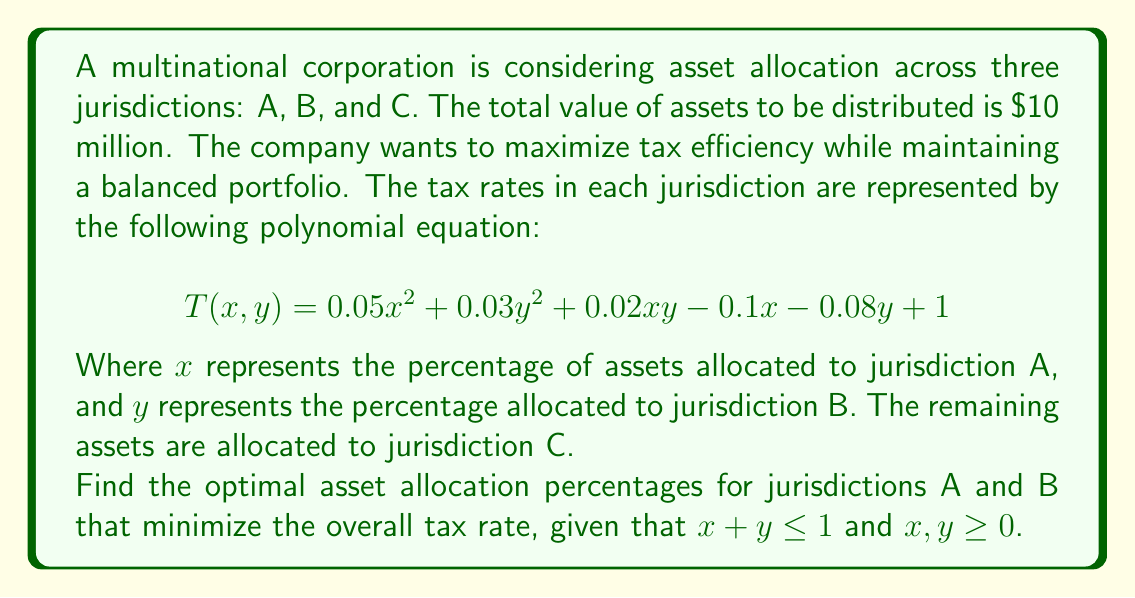Can you answer this question? To solve this problem, we need to find the minimum value of the tax rate function $T(x, y)$ subject to the given constraints. This is a multivariable optimization problem that can be solved using partial derivatives.

1. Find the partial derivatives of $T$ with respect to $x$ and $y$:

   $$\frac{\partial T}{\partial x} = 0.1x + 0.02y - 0.1$$
   $$\frac{\partial T}{\partial y} = 0.06y + 0.02x - 0.08$$

2. Set both partial derivatives to zero to find the critical points:

   $$0.1x + 0.02y - 0.1 = 0$$
   $$0.06y + 0.02x - 0.08 = 0$$

3. Solve this system of equations:

   Multiply the first equation by 3 and the second by 5:
   $$0.3x + 0.06y - 0.3 = 0$$
   $$0.3y + 0.1x - 0.4 = 0$$

   Subtracting the second equation from the first:
   $$0.2x - 0.24y + 0.1 = 0$$

   Solve for $x$ in terms of $y$:
   $$x = 1.2y - 0.5$$

4. Substitute this expression for $x$ into one of the original equations:

   $$0.06y + 0.02(1.2y - 0.5) - 0.08 = 0$$
   $$0.06y + 0.024y - 0.01 - 0.08 = 0$$
   $$0.084y = 0.09$$
   $$y = \frac{0.09}{0.084} \approx 1.0714$$

5. Calculate $x$ using the expression from step 3:

   $$x = 1.2(1.0714) - 0.5 \approx 0.7857$$

6. Check the constraint $x + y \leq 1$:

   $$0.7857 + 1.0714 = 1.8571 > 1$$

   This violates the constraint, so the optimal solution must lie on the boundary where $x + y = 1$.

7. Substitute $y = 1 - x$ into the original function:

   $$T(x) = 0.05x^2 + 0.03(1-x)^2 + 0.02x(1-x) - 0.1x - 0.08(1-x) + 1$$

8. Simplify and find the derivative:

   $$T(x) = 0.08x^2 - 0.08x + 0.95$$
   $$T'(x) = 0.16x - 0.08$$

9. Set the derivative to zero and solve:

   $$0.16x - 0.08 = 0$$
   $$x = 0.5$$

10. Therefore, $y = 1 - x = 0.5$

The optimal allocation percentages are 50% for jurisdiction A and 50% for jurisdiction B, with the remaining 0% allocated to jurisdiction C.
Answer: The optimal asset allocation is 50% ($5 million) in jurisdiction A, 50% ($5 million) in jurisdiction B, and 0% ($0) in jurisdiction C. 